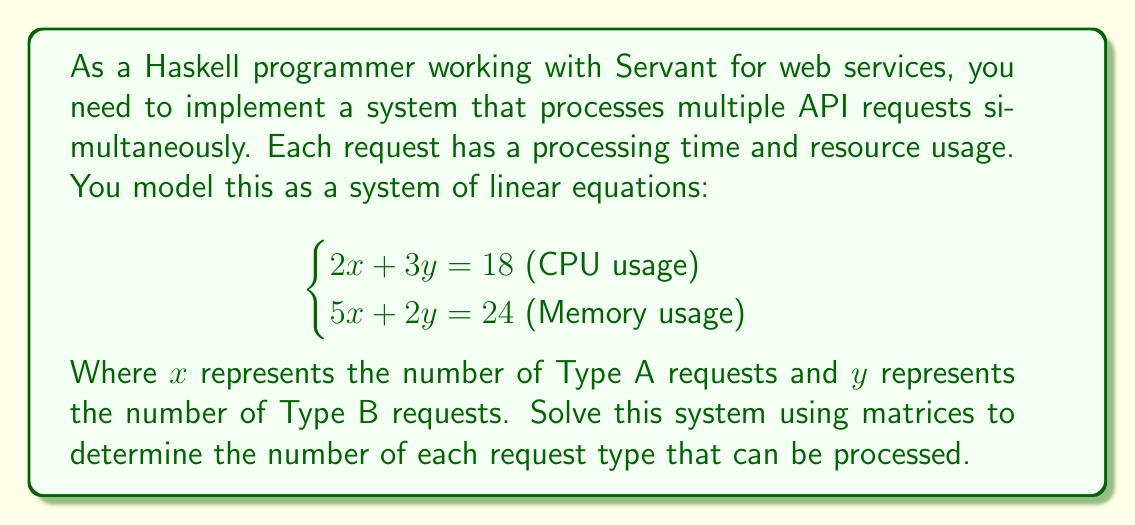Give your solution to this math problem. To solve this system using matrices, we'll follow these steps:

1) First, we'll express the system in matrix form:

   $$
   \begin{bmatrix}
   2 & 3 \\
   5 & 2
   \end{bmatrix}
   \begin{bmatrix}
   x \\
   y
   \end{bmatrix}
   =
   \begin{bmatrix}
   18 \\
   24
   \end{bmatrix}
   $$

2) We'll call the coefficient matrix A, the variable matrix X, and the constant matrix B:

   $AX = B$

3) To solve for X, we need to multiply both sides by $A^{-1}$:

   $A^{-1}AX = A^{-1}B$
   $X = A^{-1}B$

4) Now we need to find $A^{-1}$. For a 2x2 matrix, we can use the formula:

   $$A^{-1} = \frac{1}{ad-bc}\begin{bmatrix}d & -b \\ -c & a\end{bmatrix}$$

   Where $a=2$, $b=3$, $c=5$, and $d=2$.

5) Let's calculate the determinant first:

   $ad-bc = (2)(2) - (3)(5) = 4 - 15 = -11$

6) Now we can calculate $A^{-1}$:

   $$A^{-1} = \frac{1}{-11}\begin{bmatrix}2 & -3 \\ -5 & 2\end{bmatrix}$$

7) Finally, we can multiply $A^{-1}$ by B:

   $$
   X = A^{-1}B = \frac{1}{-11}\begin{bmatrix}2 & -3 \\ -5 & 2\end{bmatrix}\begin{bmatrix}18 \\ 24\end{bmatrix}
   $$

   $$
   = \frac{1}{-11}\begin{bmatrix}(2)(18) + (-3)(24) \\ (-5)(18) + (2)(24)\end{bmatrix}
   $$

   $$
   = \frac{1}{-11}\begin{bmatrix}36 - 72 \\ -90 + 48\end{bmatrix}
   $$

   $$
   = \frac{1}{-11}\begin{bmatrix}-36 \\ -42\end{bmatrix}
   $$

   $$
   = \begin{bmatrix}3.27... \\ 3.81...\end{bmatrix}
   $$

8) Since we're dealing with whole numbers of requests, we round down to the nearest integer:

   $x = 3$ and $y = 3$

Therefore, the system can process 3 Type A requests and 3 Type B requests simultaneously.
Answer: (3, 3) 